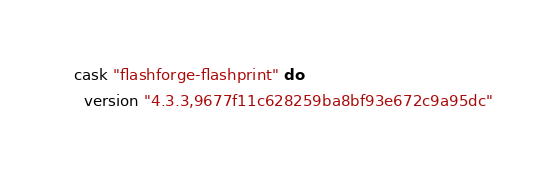Convert code to text. <code><loc_0><loc_0><loc_500><loc_500><_Ruby_>cask "flashforge-flashprint" do
  version "4.3.3,9677f11c628259ba8bf93e672c9a95dc"</code> 